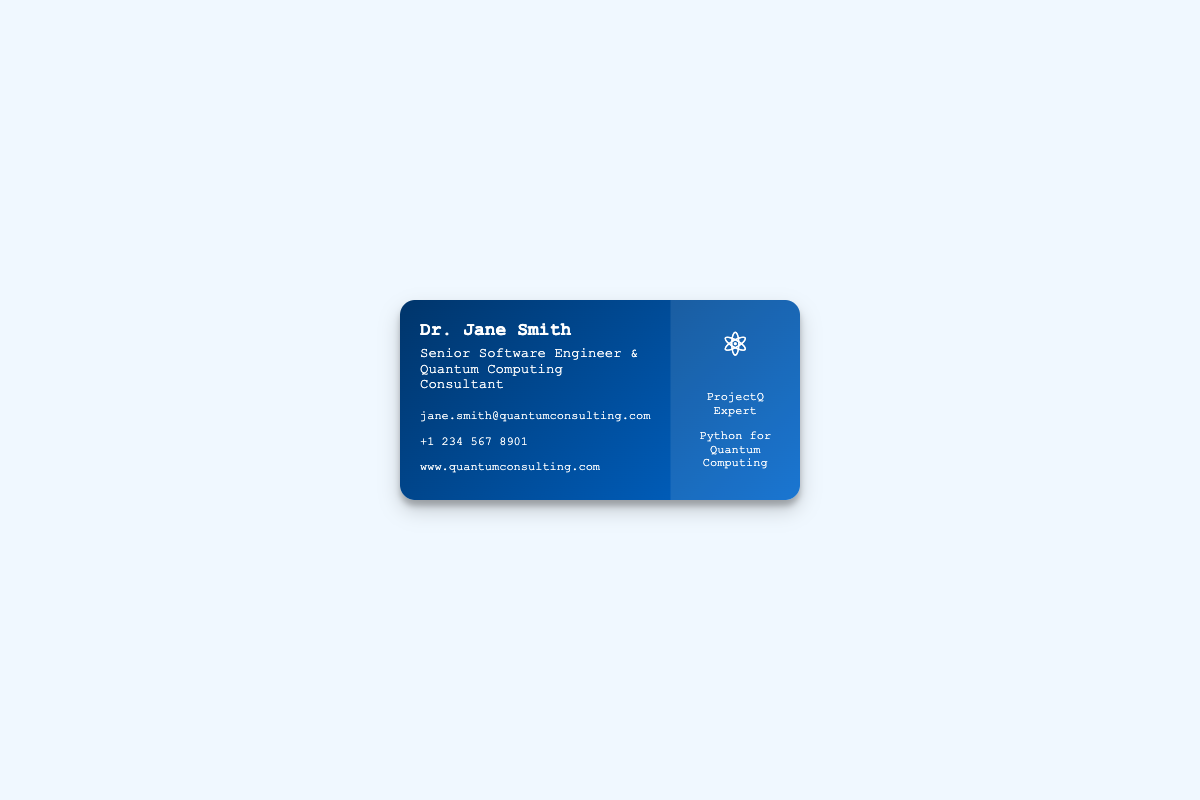What is the name of the consultant? The name appears prominently at the top of the card as part of the identification of the consultant.
Answer: Dr. Jane Smith What is the title of the consultant? The title lists the primary roles of the individual displayed on the card, showing their expertise.
Answer: Senior Software Engineer & Quantum Computing Consultant What is the email address of Dr. Jane Smith? The card provides the contact information which includes email, phone number and website.
Answer: jane.smith@quantumconsulting.com What phone number can be used to contact Dr. Jane Smith? The phone number is clearly stated in the contact section for easy reference.
Answer: +1 234 567 8901 What are the specializations mentioned on the card? The specializations describe the areas of expertise that Dr. Jane Smith focuses on within quantum computing.
Answer: Quantum Algorithms • Quantum Circuit Design • Quantum Error Correction • Quantum Cryptography • Quantum Machine Learning What does the icon represent on the right side of the card? The icon is symbolic and represents the field of quantum computing, adding visual interest to the card.
Answer: Atom What framework is mentioned as an area of expertise? The specific framework highlighted indicates proficiency in tools used for quantum programming.
Answer: ProjectQ Expert What programming language is emphasized for quantum computing in the card? The card identifies the programming language that is essential for quantum computing projects and consulting.
Answer: Python for Quantum Computing 